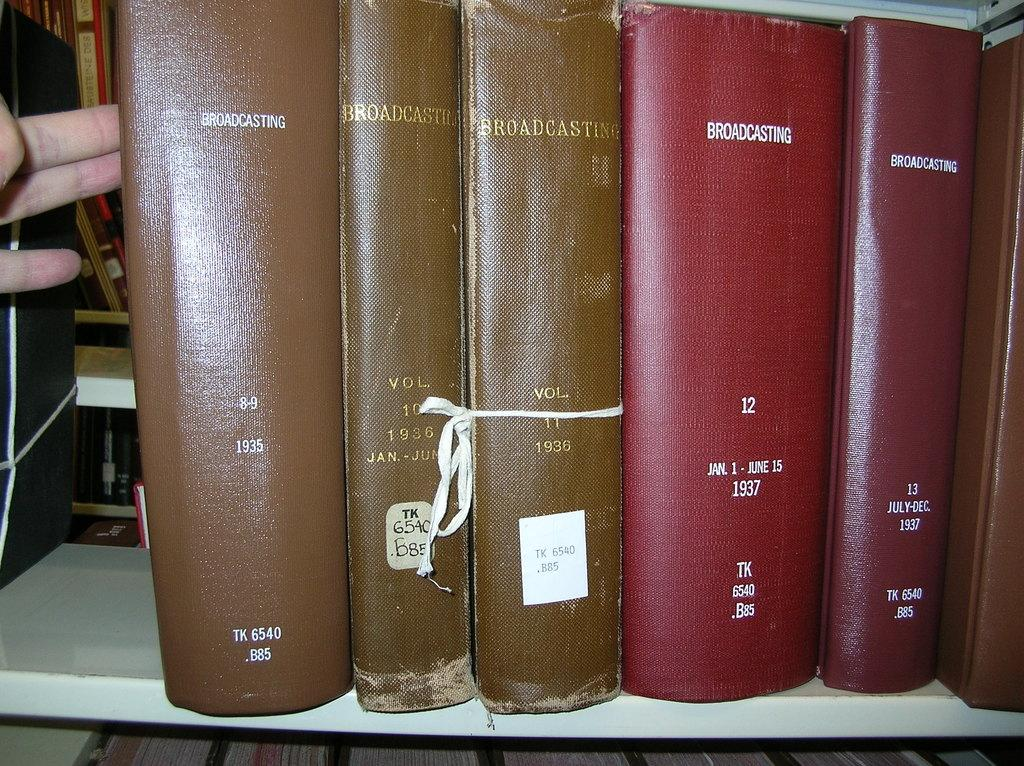<image>
Provide a brief description of the given image. A thick red book about broadcasting sits on a library shelf. 